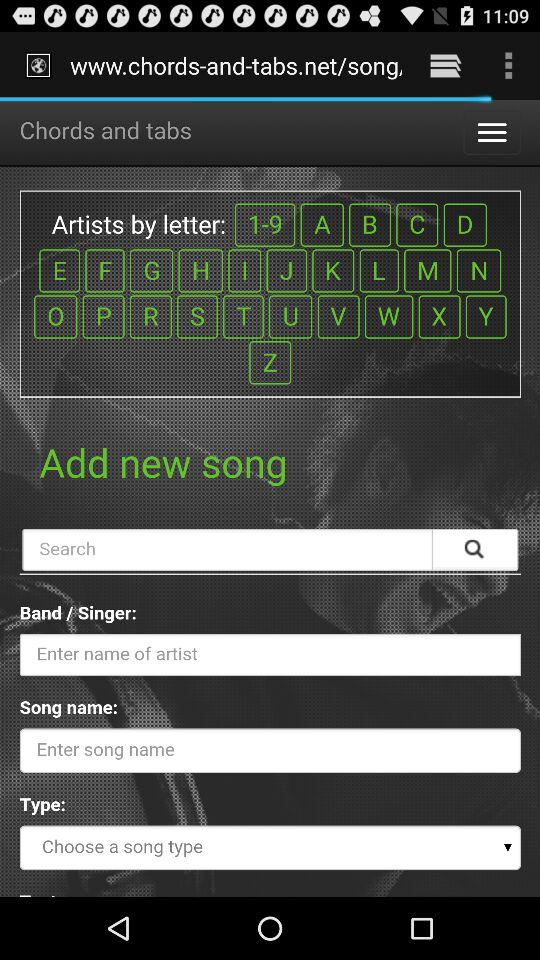What details are needed to add a new song? Details needed to add a new song are the band or singer, song name and type. 